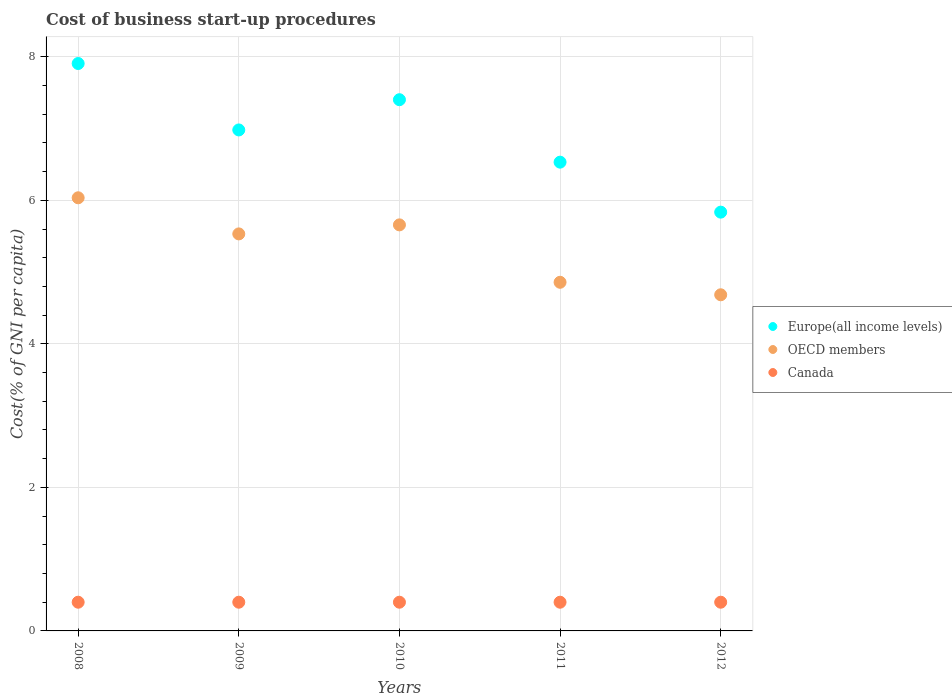What is the cost of business start-up procedures in Europe(all income levels) in 2010?
Provide a succinct answer. 7.4. Across all years, what is the maximum cost of business start-up procedures in Canada?
Make the answer very short. 0.4. Across all years, what is the minimum cost of business start-up procedures in Europe(all income levels)?
Your response must be concise. 5.84. In which year was the cost of business start-up procedures in Europe(all income levels) maximum?
Offer a terse response. 2008. In which year was the cost of business start-up procedures in Europe(all income levels) minimum?
Ensure brevity in your answer.  2012. What is the total cost of business start-up procedures in Europe(all income levels) in the graph?
Offer a very short reply. 34.66. What is the difference between the cost of business start-up procedures in OECD members in 2012 and the cost of business start-up procedures in Canada in 2010?
Offer a terse response. 4.28. What is the average cost of business start-up procedures in Europe(all income levels) per year?
Give a very brief answer. 6.93. In the year 2008, what is the difference between the cost of business start-up procedures in Canada and cost of business start-up procedures in Europe(all income levels)?
Your answer should be compact. -7.51. In how many years, is the cost of business start-up procedures in Canada greater than 6.4 %?
Your answer should be compact. 0. What is the ratio of the cost of business start-up procedures in Europe(all income levels) in 2009 to that in 2010?
Ensure brevity in your answer.  0.94. What is the difference between the highest and the second highest cost of business start-up procedures in Europe(all income levels)?
Ensure brevity in your answer.  0.5. What is the difference between the highest and the lowest cost of business start-up procedures in Europe(all income levels)?
Make the answer very short. 2.07. Is the sum of the cost of business start-up procedures in OECD members in 2010 and 2012 greater than the maximum cost of business start-up procedures in Canada across all years?
Offer a very short reply. Yes. Does the cost of business start-up procedures in OECD members monotonically increase over the years?
Make the answer very short. No. Is the cost of business start-up procedures in Canada strictly greater than the cost of business start-up procedures in OECD members over the years?
Your answer should be very brief. No. How many dotlines are there?
Offer a very short reply. 3. How many years are there in the graph?
Offer a very short reply. 5. Are the values on the major ticks of Y-axis written in scientific E-notation?
Provide a short and direct response. No. Does the graph contain any zero values?
Your response must be concise. No. Does the graph contain grids?
Offer a very short reply. Yes. How many legend labels are there?
Your response must be concise. 3. What is the title of the graph?
Your answer should be compact. Cost of business start-up procedures. Does "Kenya" appear as one of the legend labels in the graph?
Your answer should be compact. No. What is the label or title of the Y-axis?
Provide a short and direct response. Cost(% of GNI per capita). What is the Cost(% of GNI per capita) in Europe(all income levels) in 2008?
Keep it short and to the point. 7.91. What is the Cost(% of GNI per capita) of OECD members in 2008?
Offer a terse response. 6.04. What is the Cost(% of GNI per capita) in Canada in 2008?
Offer a very short reply. 0.4. What is the Cost(% of GNI per capita) in Europe(all income levels) in 2009?
Offer a terse response. 6.98. What is the Cost(% of GNI per capita) of OECD members in 2009?
Make the answer very short. 5.53. What is the Cost(% of GNI per capita) in Europe(all income levels) in 2010?
Your answer should be compact. 7.4. What is the Cost(% of GNI per capita) in OECD members in 2010?
Your answer should be compact. 5.66. What is the Cost(% of GNI per capita) in Europe(all income levels) in 2011?
Your answer should be very brief. 6.53. What is the Cost(% of GNI per capita) of OECD members in 2011?
Give a very brief answer. 4.86. What is the Cost(% of GNI per capita) in Canada in 2011?
Your response must be concise. 0.4. What is the Cost(% of GNI per capita) of Europe(all income levels) in 2012?
Ensure brevity in your answer.  5.84. What is the Cost(% of GNI per capita) of OECD members in 2012?
Provide a short and direct response. 4.68. What is the Cost(% of GNI per capita) of Canada in 2012?
Offer a very short reply. 0.4. Across all years, what is the maximum Cost(% of GNI per capita) in Europe(all income levels)?
Offer a very short reply. 7.91. Across all years, what is the maximum Cost(% of GNI per capita) of OECD members?
Offer a terse response. 6.04. Across all years, what is the maximum Cost(% of GNI per capita) in Canada?
Keep it short and to the point. 0.4. Across all years, what is the minimum Cost(% of GNI per capita) of Europe(all income levels)?
Give a very brief answer. 5.84. Across all years, what is the minimum Cost(% of GNI per capita) of OECD members?
Offer a very short reply. 4.68. What is the total Cost(% of GNI per capita) of Europe(all income levels) in the graph?
Your response must be concise. 34.66. What is the total Cost(% of GNI per capita) of OECD members in the graph?
Your response must be concise. 26.77. What is the total Cost(% of GNI per capita) in Canada in the graph?
Ensure brevity in your answer.  2. What is the difference between the Cost(% of GNI per capita) in Europe(all income levels) in 2008 and that in 2009?
Your answer should be very brief. 0.93. What is the difference between the Cost(% of GNI per capita) in OECD members in 2008 and that in 2009?
Ensure brevity in your answer.  0.5. What is the difference between the Cost(% of GNI per capita) of Canada in 2008 and that in 2009?
Your response must be concise. 0. What is the difference between the Cost(% of GNI per capita) of Europe(all income levels) in 2008 and that in 2010?
Offer a terse response. 0.5. What is the difference between the Cost(% of GNI per capita) of OECD members in 2008 and that in 2010?
Provide a succinct answer. 0.38. What is the difference between the Cost(% of GNI per capita) in Europe(all income levels) in 2008 and that in 2011?
Keep it short and to the point. 1.37. What is the difference between the Cost(% of GNI per capita) of OECD members in 2008 and that in 2011?
Provide a succinct answer. 1.18. What is the difference between the Cost(% of GNI per capita) of Europe(all income levels) in 2008 and that in 2012?
Make the answer very short. 2.07. What is the difference between the Cost(% of GNI per capita) in OECD members in 2008 and that in 2012?
Ensure brevity in your answer.  1.35. What is the difference between the Cost(% of GNI per capita) of Europe(all income levels) in 2009 and that in 2010?
Offer a terse response. -0.42. What is the difference between the Cost(% of GNI per capita) in OECD members in 2009 and that in 2010?
Make the answer very short. -0.13. What is the difference between the Cost(% of GNI per capita) in Canada in 2009 and that in 2010?
Keep it short and to the point. 0. What is the difference between the Cost(% of GNI per capita) of Europe(all income levels) in 2009 and that in 2011?
Give a very brief answer. 0.45. What is the difference between the Cost(% of GNI per capita) of OECD members in 2009 and that in 2011?
Keep it short and to the point. 0.67. What is the difference between the Cost(% of GNI per capita) of Canada in 2009 and that in 2011?
Keep it short and to the point. 0. What is the difference between the Cost(% of GNI per capita) in Europe(all income levels) in 2009 and that in 2012?
Offer a very short reply. 1.15. What is the difference between the Cost(% of GNI per capita) of OECD members in 2009 and that in 2012?
Offer a terse response. 0.85. What is the difference between the Cost(% of GNI per capita) of Europe(all income levels) in 2010 and that in 2011?
Make the answer very short. 0.87. What is the difference between the Cost(% of GNI per capita) in OECD members in 2010 and that in 2011?
Your answer should be compact. 0.8. What is the difference between the Cost(% of GNI per capita) in Canada in 2010 and that in 2011?
Offer a very short reply. 0. What is the difference between the Cost(% of GNI per capita) in Europe(all income levels) in 2010 and that in 2012?
Ensure brevity in your answer.  1.57. What is the difference between the Cost(% of GNI per capita) of OECD members in 2010 and that in 2012?
Give a very brief answer. 0.97. What is the difference between the Cost(% of GNI per capita) of Europe(all income levels) in 2011 and that in 2012?
Ensure brevity in your answer.  0.7. What is the difference between the Cost(% of GNI per capita) in OECD members in 2011 and that in 2012?
Your answer should be very brief. 0.17. What is the difference between the Cost(% of GNI per capita) of Canada in 2011 and that in 2012?
Keep it short and to the point. 0. What is the difference between the Cost(% of GNI per capita) in Europe(all income levels) in 2008 and the Cost(% of GNI per capita) in OECD members in 2009?
Offer a very short reply. 2.37. What is the difference between the Cost(% of GNI per capita) of Europe(all income levels) in 2008 and the Cost(% of GNI per capita) of Canada in 2009?
Your response must be concise. 7.51. What is the difference between the Cost(% of GNI per capita) in OECD members in 2008 and the Cost(% of GNI per capita) in Canada in 2009?
Give a very brief answer. 5.64. What is the difference between the Cost(% of GNI per capita) in Europe(all income levels) in 2008 and the Cost(% of GNI per capita) in OECD members in 2010?
Your answer should be very brief. 2.25. What is the difference between the Cost(% of GNI per capita) in Europe(all income levels) in 2008 and the Cost(% of GNI per capita) in Canada in 2010?
Provide a short and direct response. 7.51. What is the difference between the Cost(% of GNI per capita) in OECD members in 2008 and the Cost(% of GNI per capita) in Canada in 2010?
Give a very brief answer. 5.64. What is the difference between the Cost(% of GNI per capita) of Europe(all income levels) in 2008 and the Cost(% of GNI per capita) of OECD members in 2011?
Give a very brief answer. 3.05. What is the difference between the Cost(% of GNI per capita) of Europe(all income levels) in 2008 and the Cost(% of GNI per capita) of Canada in 2011?
Your response must be concise. 7.51. What is the difference between the Cost(% of GNI per capita) of OECD members in 2008 and the Cost(% of GNI per capita) of Canada in 2011?
Give a very brief answer. 5.64. What is the difference between the Cost(% of GNI per capita) in Europe(all income levels) in 2008 and the Cost(% of GNI per capita) in OECD members in 2012?
Offer a terse response. 3.22. What is the difference between the Cost(% of GNI per capita) in Europe(all income levels) in 2008 and the Cost(% of GNI per capita) in Canada in 2012?
Make the answer very short. 7.51. What is the difference between the Cost(% of GNI per capita) in OECD members in 2008 and the Cost(% of GNI per capita) in Canada in 2012?
Make the answer very short. 5.64. What is the difference between the Cost(% of GNI per capita) of Europe(all income levels) in 2009 and the Cost(% of GNI per capita) of OECD members in 2010?
Offer a very short reply. 1.32. What is the difference between the Cost(% of GNI per capita) in Europe(all income levels) in 2009 and the Cost(% of GNI per capita) in Canada in 2010?
Ensure brevity in your answer.  6.58. What is the difference between the Cost(% of GNI per capita) of OECD members in 2009 and the Cost(% of GNI per capita) of Canada in 2010?
Offer a terse response. 5.13. What is the difference between the Cost(% of GNI per capita) of Europe(all income levels) in 2009 and the Cost(% of GNI per capita) of OECD members in 2011?
Offer a terse response. 2.12. What is the difference between the Cost(% of GNI per capita) of Europe(all income levels) in 2009 and the Cost(% of GNI per capita) of Canada in 2011?
Offer a very short reply. 6.58. What is the difference between the Cost(% of GNI per capita) of OECD members in 2009 and the Cost(% of GNI per capita) of Canada in 2011?
Offer a terse response. 5.13. What is the difference between the Cost(% of GNI per capita) in Europe(all income levels) in 2009 and the Cost(% of GNI per capita) in OECD members in 2012?
Keep it short and to the point. 2.3. What is the difference between the Cost(% of GNI per capita) in Europe(all income levels) in 2009 and the Cost(% of GNI per capita) in Canada in 2012?
Provide a succinct answer. 6.58. What is the difference between the Cost(% of GNI per capita) of OECD members in 2009 and the Cost(% of GNI per capita) of Canada in 2012?
Offer a terse response. 5.13. What is the difference between the Cost(% of GNI per capita) of Europe(all income levels) in 2010 and the Cost(% of GNI per capita) of OECD members in 2011?
Provide a succinct answer. 2.54. What is the difference between the Cost(% of GNI per capita) in Europe(all income levels) in 2010 and the Cost(% of GNI per capita) in Canada in 2011?
Ensure brevity in your answer.  7. What is the difference between the Cost(% of GNI per capita) in OECD members in 2010 and the Cost(% of GNI per capita) in Canada in 2011?
Give a very brief answer. 5.26. What is the difference between the Cost(% of GNI per capita) in Europe(all income levels) in 2010 and the Cost(% of GNI per capita) in OECD members in 2012?
Your response must be concise. 2.72. What is the difference between the Cost(% of GNI per capita) of Europe(all income levels) in 2010 and the Cost(% of GNI per capita) of Canada in 2012?
Offer a terse response. 7. What is the difference between the Cost(% of GNI per capita) in OECD members in 2010 and the Cost(% of GNI per capita) in Canada in 2012?
Make the answer very short. 5.26. What is the difference between the Cost(% of GNI per capita) in Europe(all income levels) in 2011 and the Cost(% of GNI per capita) in OECD members in 2012?
Your response must be concise. 1.85. What is the difference between the Cost(% of GNI per capita) of Europe(all income levels) in 2011 and the Cost(% of GNI per capita) of Canada in 2012?
Your answer should be very brief. 6.13. What is the difference between the Cost(% of GNI per capita) in OECD members in 2011 and the Cost(% of GNI per capita) in Canada in 2012?
Your response must be concise. 4.46. What is the average Cost(% of GNI per capita) in Europe(all income levels) per year?
Offer a terse response. 6.93. What is the average Cost(% of GNI per capita) of OECD members per year?
Offer a terse response. 5.35. What is the average Cost(% of GNI per capita) of Canada per year?
Keep it short and to the point. 0.4. In the year 2008, what is the difference between the Cost(% of GNI per capita) in Europe(all income levels) and Cost(% of GNI per capita) in OECD members?
Make the answer very short. 1.87. In the year 2008, what is the difference between the Cost(% of GNI per capita) of Europe(all income levels) and Cost(% of GNI per capita) of Canada?
Your answer should be compact. 7.51. In the year 2008, what is the difference between the Cost(% of GNI per capita) of OECD members and Cost(% of GNI per capita) of Canada?
Your answer should be very brief. 5.64. In the year 2009, what is the difference between the Cost(% of GNI per capita) in Europe(all income levels) and Cost(% of GNI per capita) in OECD members?
Provide a short and direct response. 1.45. In the year 2009, what is the difference between the Cost(% of GNI per capita) of Europe(all income levels) and Cost(% of GNI per capita) of Canada?
Offer a terse response. 6.58. In the year 2009, what is the difference between the Cost(% of GNI per capita) of OECD members and Cost(% of GNI per capita) of Canada?
Offer a very short reply. 5.13. In the year 2010, what is the difference between the Cost(% of GNI per capita) of Europe(all income levels) and Cost(% of GNI per capita) of OECD members?
Ensure brevity in your answer.  1.74. In the year 2010, what is the difference between the Cost(% of GNI per capita) of Europe(all income levels) and Cost(% of GNI per capita) of Canada?
Give a very brief answer. 7. In the year 2010, what is the difference between the Cost(% of GNI per capita) in OECD members and Cost(% of GNI per capita) in Canada?
Give a very brief answer. 5.26. In the year 2011, what is the difference between the Cost(% of GNI per capita) in Europe(all income levels) and Cost(% of GNI per capita) in OECD members?
Your answer should be compact. 1.67. In the year 2011, what is the difference between the Cost(% of GNI per capita) of Europe(all income levels) and Cost(% of GNI per capita) of Canada?
Offer a terse response. 6.13. In the year 2011, what is the difference between the Cost(% of GNI per capita) in OECD members and Cost(% of GNI per capita) in Canada?
Your answer should be compact. 4.46. In the year 2012, what is the difference between the Cost(% of GNI per capita) of Europe(all income levels) and Cost(% of GNI per capita) of OECD members?
Your response must be concise. 1.15. In the year 2012, what is the difference between the Cost(% of GNI per capita) in Europe(all income levels) and Cost(% of GNI per capita) in Canada?
Offer a terse response. 5.44. In the year 2012, what is the difference between the Cost(% of GNI per capita) of OECD members and Cost(% of GNI per capita) of Canada?
Your answer should be very brief. 4.28. What is the ratio of the Cost(% of GNI per capita) of Europe(all income levels) in 2008 to that in 2009?
Your response must be concise. 1.13. What is the ratio of the Cost(% of GNI per capita) of OECD members in 2008 to that in 2009?
Give a very brief answer. 1.09. What is the ratio of the Cost(% of GNI per capita) in Canada in 2008 to that in 2009?
Your response must be concise. 1. What is the ratio of the Cost(% of GNI per capita) in Europe(all income levels) in 2008 to that in 2010?
Offer a very short reply. 1.07. What is the ratio of the Cost(% of GNI per capita) of OECD members in 2008 to that in 2010?
Make the answer very short. 1.07. What is the ratio of the Cost(% of GNI per capita) of Canada in 2008 to that in 2010?
Offer a terse response. 1. What is the ratio of the Cost(% of GNI per capita) in Europe(all income levels) in 2008 to that in 2011?
Provide a succinct answer. 1.21. What is the ratio of the Cost(% of GNI per capita) of OECD members in 2008 to that in 2011?
Provide a succinct answer. 1.24. What is the ratio of the Cost(% of GNI per capita) of Europe(all income levels) in 2008 to that in 2012?
Provide a short and direct response. 1.35. What is the ratio of the Cost(% of GNI per capita) in OECD members in 2008 to that in 2012?
Your answer should be compact. 1.29. What is the ratio of the Cost(% of GNI per capita) in Europe(all income levels) in 2009 to that in 2010?
Your answer should be very brief. 0.94. What is the ratio of the Cost(% of GNI per capita) in OECD members in 2009 to that in 2010?
Provide a short and direct response. 0.98. What is the ratio of the Cost(% of GNI per capita) in Canada in 2009 to that in 2010?
Ensure brevity in your answer.  1. What is the ratio of the Cost(% of GNI per capita) in Europe(all income levels) in 2009 to that in 2011?
Ensure brevity in your answer.  1.07. What is the ratio of the Cost(% of GNI per capita) in OECD members in 2009 to that in 2011?
Give a very brief answer. 1.14. What is the ratio of the Cost(% of GNI per capita) of Canada in 2009 to that in 2011?
Your answer should be very brief. 1. What is the ratio of the Cost(% of GNI per capita) in Europe(all income levels) in 2009 to that in 2012?
Keep it short and to the point. 1.2. What is the ratio of the Cost(% of GNI per capita) of OECD members in 2009 to that in 2012?
Your response must be concise. 1.18. What is the ratio of the Cost(% of GNI per capita) in Europe(all income levels) in 2010 to that in 2011?
Make the answer very short. 1.13. What is the ratio of the Cost(% of GNI per capita) in OECD members in 2010 to that in 2011?
Ensure brevity in your answer.  1.16. What is the ratio of the Cost(% of GNI per capita) of Canada in 2010 to that in 2011?
Offer a terse response. 1. What is the ratio of the Cost(% of GNI per capita) in Europe(all income levels) in 2010 to that in 2012?
Keep it short and to the point. 1.27. What is the ratio of the Cost(% of GNI per capita) in OECD members in 2010 to that in 2012?
Your answer should be compact. 1.21. What is the ratio of the Cost(% of GNI per capita) of Canada in 2010 to that in 2012?
Your answer should be very brief. 1. What is the ratio of the Cost(% of GNI per capita) of Europe(all income levels) in 2011 to that in 2012?
Your response must be concise. 1.12. What is the ratio of the Cost(% of GNI per capita) of OECD members in 2011 to that in 2012?
Provide a succinct answer. 1.04. What is the difference between the highest and the second highest Cost(% of GNI per capita) in Europe(all income levels)?
Keep it short and to the point. 0.5. What is the difference between the highest and the second highest Cost(% of GNI per capita) in OECD members?
Provide a succinct answer. 0.38. What is the difference between the highest and the lowest Cost(% of GNI per capita) in Europe(all income levels)?
Provide a short and direct response. 2.07. What is the difference between the highest and the lowest Cost(% of GNI per capita) in OECD members?
Provide a short and direct response. 1.35. What is the difference between the highest and the lowest Cost(% of GNI per capita) in Canada?
Offer a very short reply. 0. 